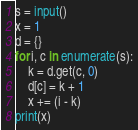<code> <loc_0><loc_0><loc_500><loc_500><_Python_>s = input()
x = 1
d = {}
for i, c in enumerate(s):
    k = d.get(c, 0)
    d[c] = k + 1
    x += (i - k)
print(x)
</code> 